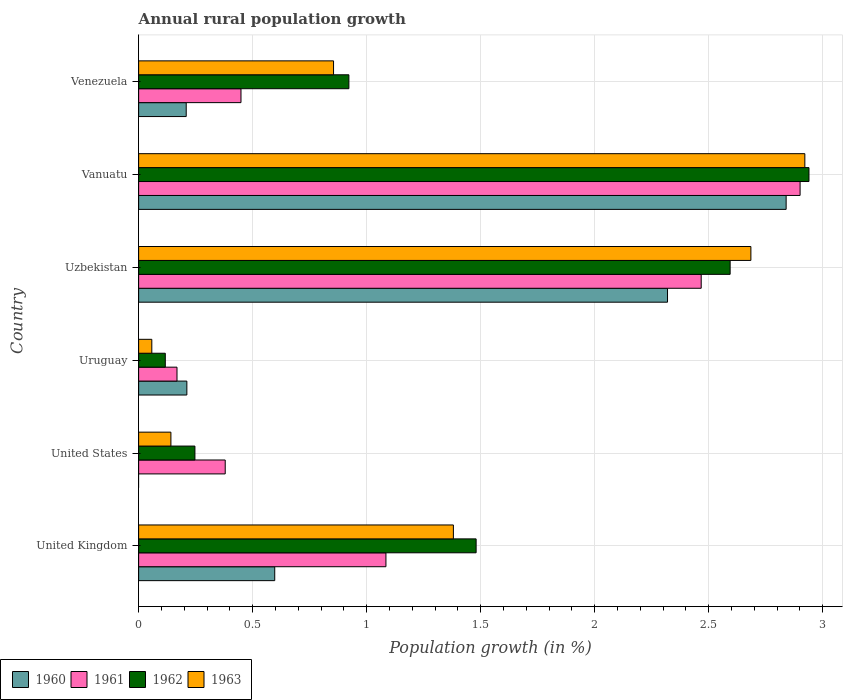Are the number of bars per tick equal to the number of legend labels?
Give a very brief answer. No. Are the number of bars on each tick of the Y-axis equal?
Keep it short and to the point. No. How many bars are there on the 3rd tick from the bottom?
Provide a short and direct response. 4. What is the label of the 3rd group of bars from the top?
Offer a terse response. Uzbekistan. In how many cases, is the number of bars for a given country not equal to the number of legend labels?
Keep it short and to the point. 1. What is the percentage of rural population growth in 1963 in Venezuela?
Your answer should be very brief. 0.85. Across all countries, what is the maximum percentage of rural population growth in 1961?
Provide a short and direct response. 2.9. Across all countries, what is the minimum percentage of rural population growth in 1962?
Offer a terse response. 0.12. In which country was the percentage of rural population growth in 1962 maximum?
Your answer should be very brief. Vanuatu. What is the total percentage of rural population growth in 1961 in the graph?
Keep it short and to the point. 7.45. What is the difference between the percentage of rural population growth in 1960 in Uzbekistan and that in Vanuatu?
Your answer should be compact. -0.52. What is the difference between the percentage of rural population growth in 1960 in Uzbekistan and the percentage of rural population growth in 1962 in Vanuatu?
Offer a terse response. -0.62. What is the average percentage of rural population growth in 1962 per country?
Provide a succinct answer. 1.38. What is the difference between the percentage of rural population growth in 1963 and percentage of rural population growth in 1960 in Vanuatu?
Keep it short and to the point. 0.08. In how many countries, is the percentage of rural population growth in 1960 greater than 0.8 %?
Your answer should be compact. 2. What is the ratio of the percentage of rural population growth in 1961 in Uruguay to that in Venezuela?
Give a very brief answer. 0.37. Is the percentage of rural population growth in 1961 in United States less than that in Vanuatu?
Offer a very short reply. Yes. Is the difference between the percentage of rural population growth in 1963 in United Kingdom and Vanuatu greater than the difference between the percentage of rural population growth in 1960 in United Kingdom and Vanuatu?
Provide a short and direct response. Yes. What is the difference between the highest and the second highest percentage of rural population growth in 1962?
Your answer should be very brief. 0.35. What is the difference between the highest and the lowest percentage of rural population growth in 1961?
Keep it short and to the point. 2.73. In how many countries, is the percentage of rural population growth in 1960 greater than the average percentage of rural population growth in 1960 taken over all countries?
Provide a succinct answer. 2. Is the sum of the percentage of rural population growth in 1963 in Uruguay and Venezuela greater than the maximum percentage of rural population growth in 1960 across all countries?
Ensure brevity in your answer.  No. Is it the case that in every country, the sum of the percentage of rural population growth in 1963 and percentage of rural population growth in 1960 is greater than the percentage of rural population growth in 1962?
Keep it short and to the point. No. How many bars are there?
Offer a very short reply. 23. How many countries are there in the graph?
Ensure brevity in your answer.  6. What is the difference between two consecutive major ticks on the X-axis?
Make the answer very short. 0.5. Does the graph contain any zero values?
Provide a short and direct response. Yes. How are the legend labels stacked?
Keep it short and to the point. Horizontal. What is the title of the graph?
Provide a succinct answer. Annual rural population growth. Does "1986" appear as one of the legend labels in the graph?
Your answer should be compact. No. What is the label or title of the X-axis?
Offer a terse response. Population growth (in %). What is the label or title of the Y-axis?
Offer a terse response. Country. What is the Population growth (in %) in 1960 in United Kingdom?
Offer a terse response. 0.6. What is the Population growth (in %) of 1961 in United Kingdom?
Your answer should be compact. 1.08. What is the Population growth (in %) of 1962 in United Kingdom?
Keep it short and to the point. 1.48. What is the Population growth (in %) in 1963 in United Kingdom?
Make the answer very short. 1.38. What is the Population growth (in %) in 1960 in United States?
Provide a succinct answer. 0. What is the Population growth (in %) of 1961 in United States?
Make the answer very short. 0.38. What is the Population growth (in %) of 1962 in United States?
Your answer should be very brief. 0.25. What is the Population growth (in %) in 1963 in United States?
Your answer should be compact. 0.14. What is the Population growth (in %) of 1960 in Uruguay?
Your response must be concise. 0.21. What is the Population growth (in %) of 1961 in Uruguay?
Provide a succinct answer. 0.17. What is the Population growth (in %) in 1962 in Uruguay?
Keep it short and to the point. 0.12. What is the Population growth (in %) in 1963 in Uruguay?
Your response must be concise. 0.06. What is the Population growth (in %) in 1960 in Uzbekistan?
Provide a short and direct response. 2.32. What is the Population growth (in %) in 1961 in Uzbekistan?
Ensure brevity in your answer.  2.47. What is the Population growth (in %) in 1962 in Uzbekistan?
Offer a terse response. 2.59. What is the Population growth (in %) of 1963 in Uzbekistan?
Offer a terse response. 2.69. What is the Population growth (in %) of 1960 in Vanuatu?
Offer a terse response. 2.84. What is the Population growth (in %) in 1961 in Vanuatu?
Ensure brevity in your answer.  2.9. What is the Population growth (in %) of 1962 in Vanuatu?
Offer a terse response. 2.94. What is the Population growth (in %) of 1963 in Vanuatu?
Provide a short and direct response. 2.92. What is the Population growth (in %) of 1960 in Venezuela?
Provide a succinct answer. 0.21. What is the Population growth (in %) of 1961 in Venezuela?
Offer a very short reply. 0.45. What is the Population growth (in %) in 1962 in Venezuela?
Make the answer very short. 0.92. What is the Population growth (in %) of 1963 in Venezuela?
Make the answer very short. 0.85. Across all countries, what is the maximum Population growth (in %) in 1960?
Your answer should be very brief. 2.84. Across all countries, what is the maximum Population growth (in %) in 1961?
Keep it short and to the point. 2.9. Across all countries, what is the maximum Population growth (in %) in 1962?
Provide a short and direct response. 2.94. Across all countries, what is the maximum Population growth (in %) of 1963?
Offer a terse response. 2.92. Across all countries, what is the minimum Population growth (in %) of 1960?
Provide a succinct answer. 0. Across all countries, what is the minimum Population growth (in %) of 1961?
Offer a very short reply. 0.17. Across all countries, what is the minimum Population growth (in %) of 1962?
Give a very brief answer. 0.12. Across all countries, what is the minimum Population growth (in %) in 1963?
Your answer should be compact. 0.06. What is the total Population growth (in %) in 1960 in the graph?
Provide a short and direct response. 6.18. What is the total Population growth (in %) of 1961 in the graph?
Provide a short and direct response. 7.45. What is the total Population growth (in %) in 1962 in the graph?
Provide a short and direct response. 8.3. What is the total Population growth (in %) of 1963 in the graph?
Offer a very short reply. 8.04. What is the difference between the Population growth (in %) in 1961 in United Kingdom and that in United States?
Your answer should be very brief. 0.7. What is the difference between the Population growth (in %) in 1962 in United Kingdom and that in United States?
Your answer should be very brief. 1.23. What is the difference between the Population growth (in %) of 1963 in United Kingdom and that in United States?
Offer a terse response. 1.24. What is the difference between the Population growth (in %) in 1960 in United Kingdom and that in Uruguay?
Offer a very short reply. 0.39. What is the difference between the Population growth (in %) of 1961 in United Kingdom and that in Uruguay?
Your answer should be very brief. 0.92. What is the difference between the Population growth (in %) in 1962 in United Kingdom and that in Uruguay?
Make the answer very short. 1.36. What is the difference between the Population growth (in %) in 1963 in United Kingdom and that in Uruguay?
Provide a succinct answer. 1.32. What is the difference between the Population growth (in %) of 1960 in United Kingdom and that in Uzbekistan?
Your response must be concise. -1.72. What is the difference between the Population growth (in %) of 1961 in United Kingdom and that in Uzbekistan?
Offer a terse response. -1.38. What is the difference between the Population growth (in %) of 1962 in United Kingdom and that in Uzbekistan?
Provide a succinct answer. -1.11. What is the difference between the Population growth (in %) of 1963 in United Kingdom and that in Uzbekistan?
Your answer should be compact. -1.3. What is the difference between the Population growth (in %) of 1960 in United Kingdom and that in Vanuatu?
Your answer should be compact. -2.24. What is the difference between the Population growth (in %) in 1961 in United Kingdom and that in Vanuatu?
Your response must be concise. -1.82. What is the difference between the Population growth (in %) in 1962 in United Kingdom and that in Vanuatu?
Provide a short and direct response. -1.46. What is the difference between the Population growth (in %) in 1963 in United Kingdom and that in Vanuatu?
Ensure brevity in your answer.  -1.54. What is the difference between the Population growth (in %) in 1960 in United Kingdom and that in Venezuela?
Give a very brief answer. 0.39. What is the difference between the Population growth (in %) in 1961 in United Kingdom and that in Venezuela?
Keep it short and to the point. 0.64. What is the difference between the Population growth (in %) in 1962 in United Kingdom and that in Venezuela?
Your answer should be compact. 0.56. What is the difference between the Population growth (in %) of 1963 in United Kingdom and that in Venezuela?
Make the answer very short. 0.53. What is the difference between the Population growth (in %) in 1961 in United States and that in Uruguay?
Your response must be concise. 0.21. What is the difference between the Population growth (in %) in 1962 in United States and that in Uruguay?
Provide a succinct answer. 0.13. What is the difference between the Population growth (in %) in 1963 in United States and that in Uruguay?
Give a very brief answer. 0.08. What is the difference between the Population growth (in %) of 1961 in United States and that in Uzbekistan?
Give a very brief answer. -2.09. What is the difference between the Population growth (in %) in 1962 in United States and that in Uzbekistan?
Provide a short and direct response. -2.35. What is the difference between the Population growth (in %) of 1963 in United States and that in Uzbekistan?
Offer a very short reply. -2.54. What is the difference between the Population growth (in %) in 1961 in United States and that in Vanuatu?
Offer a very short reply. -2.52. What is the difference between the Population growth (in %) of 1962 in United States and that in Vanuatu?
Provide a succinct answer. -2.69. What is the difference between the Population growth (in %) of 1963 in United States and that in Vanuatu?
Ensure brevity in your answer.  -2.78. What is the difference between the Population growth (in %) of 1961 in United States and that in Venezuela?
Make the answer very short. -0.07. What is the difference between the Population growth (in %) in 1962 in United States and that in Venezuela?
Provide a succinct answer. -0.68. What is the difference between the Population growth (in %) of 1963 in United States and that in Venezuela?
Your response must be concise. -0.71. What is the difference between the Population growth (in %) of 1960 in Uruguay and that in Uzbekistan?
Your answer should be compact. -2.11. What is the difference between the Population growth (in %) in 1961 in Uruguay and that in Uzbekistan?
Make the answer very short. -2.3. What is the difference between the Population growth (in %) in 1962 in Uruguay and that in Uzbekistan?
Keep it short and to the point. -2.48. What is the difference between the Population growth (in %) of 1963 in Uruguay and that in Uzbekistan?
Your answer should be very brief. -2.63. What is the difference between the Population growth (in %) of 1960 in Uruguay and that in Vanuatu?
Offer a terse response. -2.63. What is the difference between the Population growth (in %) of 1961 in Uruguay and that in Vanuatu?
Offer a terse response. -2.73. What is the difference between the Population growth (in %) in 1962 in Uruguay and that in Vanuatu?
Provide a succinct answer. -2.82. What is the difference between the Population growth (in %) of 1963 in Uruguay and that in Vanuatu?
Provide a short and direct response. -2.86. What is the difference between the Population growth (in %) in 1960 in Uruguay and that in Venezuela?
Provide a short and direct response. 0. What is the difference between the Population growth (in %) in 1961 in Uruguay and that in Venezuela?
Your response must be concise. -0.28. What is the difference between the Population growth (in %) in 1962 in Uruguay and that in Venezuela?
Your answer should be very brief. -0.81. What is the difference between the Population growth (in %) in 1963 in Uruguay and that in Venezuela?
Keep it short and to the point. -0.8. What is the difference between the Population growth (in %) in 1960 in Uzbekistan and that in Vanuatu?
Offer a very short reply. -0.52. What is the difference between the Population growth (in %) of 1961 in Uzbekistan and that in Vanuatu?
Offer a terse response. -0.43. What is the difference between the Population growth (in %) in 1962 in Uzbekistan and that in Vanuatu?
Your response must be concise. -0.35. What is the difference between the Population growth (in %) in 1963 in Uzbekistan and that in Vanuatu?
Offer a terse response. -0.24. What is the difference between the Population growth (in %) in 1960 in Uzbekistan and that in Venezuela?
Provide a short and direct response. 2.11. What is the difference between the Population growth (in %) in 1961 in Uzbekistan and that in Venezuela?
Give a very brief answer. 2.02. What is the difference between the Population growth (in %) of 1962 in Uzbekistan and that in Venezuela?
Your response must be concise. 1.67. What is the difference between the Population growth (in %) in 1963 in Uzbekistan and that in Venezuela?
Offer a terse response. 1.83. What is the difference between the Population growth (in %) in 1960 in Vanuatu and that in Venezuela?
Your answer should be very brief. 2.63. What is the difference between the Population growth (in %) in 1961 in Vanuatu and that in Venezuela?
Keep it short and to the point. 2.45. What is the difference between the Population growth (in %) of 1962 in Vanuatu and that in Venezuela?
Ensure brevity in your answer.  2.02. What is the difference between the Population growth (in %) of 1963 in Vanuatu and that in Venezuela?
Give a very brief answer. 2.07. What is the difference between the Population growth (in %) in 1960 in United Kingdom and the Population growth (in %) in 1961 in United States?
Offer a very short reply. 0.22. What is the difference between the Population growth (in %) in 1960 in United Kingdom and the Population growth (in %) in 1963 in United States?
Your answer should be very brief. 0.46. What is the difference between the Population growth (in %) in 1961 in United Kingdom and the Population growth (in %) in 1962 in United States?
Keep it short and to the point. 0.84. What is the difference between the Population growth (in %) in 1961 in United Kingdom and the Population growth (in %) in 1963 in United States?
Offer a terse response. 0.94. What is the difference between the Population growth (in %) of 1962 in United Kingdom and the Population growth (in %) of 1963 in United States?
Provide a succinct answer. 1.34. What is the difference between the Population growth (in %) in 1960 in United Kingdom and the Population growth (in %) in 1961 in Uruguay?
Your answer should be compact. 0.43. What is the difference between the Population growth (in %) of 1960 in United Kingdom and the Population growth (in %) of 1962 in Uruguay?
Keep it short and to the point. 0.48. What is the difference between the Population growth (in %) of 1960 in United Kingdom and the Population growth (in %) of 1963 in Uruguay?
Offer a very short reply. 0.54. What is the difference between the Population growth (in %) of 1961 in United Kingdom and the Population growth (in %) of 1963 in Uruguay?
Provide a succinct answer. 1.03. What is the difference between the Population growth (in %) of 1962 in United Kingdom and the Population growth (in %) of 1963 in Uruguay?
Provide a short and direct response. 1.42. What is the difference between the Population growth (in %) in 1960 in United Kingdom and the Population growth (in %) in 1961 in Uzbekistan?
Give a very brief answer. -1.87. What is the difference between the Population growth (in %) of 1960 in United Kingdom and the Population growth (in %) of 1962 in Uzbekistan?
Your answer should be very brief. -2. What is the difference between the Population growth (in %) of 1960 in United Kingdom and the Population growth (in %) of 1963 in Uzbekistan?
Provide a succinct answer. -2.09. What is the difference between the Population growth (in %) of 1961 in United Kingdom and the Population growth (in %) of 1962 in Uzbekistan?
Offer a terse response. -1.51. What is the difference between the Population growth (in %) in 1961 in United Kingdom and the Population growth (in %) in 1963 in Uzbekistan?
Ensure brevity in your answer.  -1.6. What is the difference between the Population growth (in %) in 1962 in United Kingdom and the Population growth (in %) in 1963 in Uzbekistan?
Provide a short and direct response. -1.21. What is the difference between the Population growth (in %) of 1960 in United Kingdom and the Population growth (in %) of 1961 in Vanuatu?
Offer a very short reply. -2.3. What is the difference between the Population growth (in %) in 1960 in United Kingdom and the Population growth (in %) in 1962 in Vanuatu?
Provide a short and direct response. -2.34. What is the difference between the Population growth (in %) of 1960 in United Kingdom and the Population growth (in %) of 1963 in Vanuatu?
Provide a succinct answer. -2.32. What is the difference between the Population growth (in %) in 1961 in United Kingdom and the Population growth (in %) in 1962 in Vanuatu?
Give a very brief answer. -1.86. What is the difference between the Population growth (in %) of 1961 in United Kingdom and the Population growth (in %) of 1963 in Vanuatu?
Offer a very short reply. -1.84. What is the difference between the Population growth (in %) of 1962 in United Kingdom and the Population growth (in %) of 1963 in Vanuatu?
Your answer should be compact. -1.44. What is the difference between the Population growth (in %) in 1960 in United Kingdom and the Population growth (in %) in 1961 in Venezuela?
Make the answer very short. 0.15. What is the difference between the Population growth (in %) of 1960 in United Kingdom and the Population growth (in %) of 1962 in Venezuela?
Ensure brevity in your answer.  -0.33. What is the difference between the Population growth (in %) in 1960 in United Kingdom and the Population growth (in %) in 1963 in Venezuela?
Your response must be concise. -0.26. What is the difference between the Population growth (in %) in 1961 in United Kingdom and the Population growth (in %) in 1962 in Venezuela?
Provide a succinct answer. 0.16. What is the difference between the Population growth (in %) of 1961 in United Kingdom and the Population growth (in %) of 1963 in Venezuela?
Your response must be concise. 0.23. What is the difference between the Population growth (in %) of 1962 in United Kingdom and the Population growth (in %) of 1963 in Venezuela?
Ensure brevity in your answer.  0.63. What is the difference between the Population growth (in %) in 1961 in United States and the Population growth (in %) in 1962 in Uruguay?
Provide a short and direct response. 0.26. What is the difference between the Population growth (in %) in 1961 in United States and the Population growth (in %) in 1963 in Uruguay?
Make the answer very short. 0.32. What is the difference between the Population growth (in %) in 1962 in United States and the Population growth (in %) in 1963 in Uruguay?
Provide a short and direct response. 0.19. What is the difference between the Population growth (in %) in 1961 in United States and the Population growth (in %) in 1962 in Uzbekistan?
Provide a succinct answer. -2.21. What is the difference between the Population growth (in %) of 1961 in United States and the Population growth (in %) of 1963 in Uzbekistan?
Your answer should be very brief. -2.31. What is the difference between the Population growth (in %) in 1962 in United States and the Population growth (in %) in 1963 in Uzbekistan?
Your answer should be very brief. -2.44. What is the difference between the Population growth (in %) in 1961 in United States and the Population growth (in %) in 1962 in Vanuatu?
Make the answer very short. -2.56. What is the difference between the Population growth (in %) in 1961 in United States and the Population growth (in %) in 1963 in Vanuatu?
Your answer should be very brief. -2.54. What is the difference between the Population growth (in %) in 1962 in United States and the Population growth (in %) in 1963 in Vanuatu?
Ensure brevity in your answer.  -2.67. What is the difference between the Population growth (in %) of 1961 in United States and the Population growth (in %) of 1962 in Venezuela?
Provide a succinct answer. -0.54. What is the difference between the Population growth (in %) of 1961 in United States and the Population growth (in %) of 1963 in Venezuela?
Keep it short and to the point. -0.48. What is the difference between the Population growth (in %) of 1962 in United States and the Population growth (in %) of 1963 in Venezuela?
Provide a short and direct response. -0.61. What is the difference between the Population growth (in %) in 1960 in Uruguay and the Population growth (in %) in 1961 in Uzbekistan?
Keep it short and to the point. -2.26. What is the difference between the Population growth (in %) in 1960 in Uruguay and the Population growth (in %) in 1962 in Uzbekistan?
Give a very brief answer. -2.38. What is the difference between the Population growth (in %) of 1960 in Uruguay and the Population growth (in %) of 1963 in Uzbekistan?
Keep it short and to the point. -2.47. What is the difference between the Population growth (in %) of 1961 in Uruguay and the Population growth (in %) of 1962 in Uzbekistan?
Ensure brevity in your answer.  -2.43. What is the difference between the Population growth (in %) in 1961 in Uruguay and the Population growth (in %) in 1963 in Uzbekistan?
Keep it short and to the point. -2.52. What is the difference between the Population growth (in %) of 1962 in Uruguay and the Population growth (in %) of 1963 in Uzbekistan?
Offer a very short reply. -2.57. What is the difference between the Population growth (in %) in 1960 in Uruguay and the Population growth (in %) in 1961 in Vanuatu?
Give a very brief answer. -2.69. What is the difference between the Population growth (in %) of 1960 in Uruguay and the Population growth (in %) of 1962 in Vanuatu?
Keep it short and to the point. -2.73. What is the difference between the Population growth (in %) in 1960 in Uruguay and the Population growth (in %) in 1963 in Vanuatu?
Give a very brief answer. -2.71. What is the difference between the Population growth (in %) of 1961 in Uruguay and the Population growth (in %) of 1962 in Vanuatu?
Your response must be concise. -2.77. What is the difference between the Population growth (in %) in 1961 in Uruguay and the Population growth (in %) in 1963 in Vanuatu?
Make the answer very short. -2.75. What is the difference between the Population growth (in %) in 1962 in Uruguay and the Population growth (in %) in 1963 in Vanuatu?
Your answer should be very brief. -2.8. What is the difference between the Population growth (in %) in 1960 in Uruguay and the Population growth (in %) in 1961 in Venezuela?
Offer a very short reply. -0.24. What is the difference between the Population growth (in %) in 1960 in Uruguay and the Population growth (in %) in 1962 in Venezuela?
Offer a very short reply. -0.71. What is the difference between the Population growth (in %) in 1960 in Uruguay and the Population growth (in %) in 1963 in Venezuela?
Your answer should be very brief. -0.64. What is the difference between the Population growth (in %) of 1961 in Uruguay and the Population growth (in %) of 1962 in Venezuela?
Provide a succinct answer. -0.75. What is the difference between the Population growth (in %) in 1961 in Uruguay and the Population growth (in %) in 1963 in Venezuela?
Provide a succinct answer. -0.69. What is the difference between the Population growth (in %) of 1962 in Uruguay and the Population growth (in %) of 1963 in Venezuela?
Offer a terse response. -0.74. What is the difference between the Population growth (in %) of 1960 in Uzbekistan and the Population growth (in %) of 1961 in Vanuatu?
Give a very brief answer. -0.58. What is the difference between the Population growth (in %) of 1960 in Uzbekistan and the Population growth (in %) of 1962 in Vanuatu?
Provide a succinct answer. -0.62. What is the difference between the Population growth (in %) in 1960 in Uzbekistan and the Population growth (in %) in 1963 in Vanuatu?
Offer a terse response. -0.6. What is the difference between the Population growth (in %) in 1961 in Uzbekistan and the Population growth (in %) in 1962 in Vanuatu?
Give a very brief answer. -0.47. What is the difference between the Population growth (in %) of 1961 in Uzbekistan and the Population growth (in %) of 1963 in Vanuatu?
Keep it short and to the point. -0.45. What is the difference between the Population growth (in %) of 1962 in Uzbekistan and the Population growth (in %) of 1963 in Vanuatu?
Offer a very short reply. -0.33. What is the difference between the Population growth (in %) of 1960 in Uzbekistan and the Population growth (in %) of 1961 in Venezuela?
Give a very brief answer. 1.87. What is the difference between the Population growth (in %) in 1960 in Uzbekistan and the Population growth (in %) in 1962 in Venezuela?
Your response must be concise. 1.4. What is the difference between the Population growth (in %) in 1960 in Uzbekistan and the Population growth (in %) in 1963 in Venezuela?
Provide a succinct answer. 1.46. What is the difference between the Population growth (in %) of 1961 in Uzbekistan and the Population growth (in %) of 1962 in Venezuela?
Your answer should be very brief. 1.55. What is the difference between the Population growth (in %) of 1961 in Uzbekistan and the Population growth (in %) of 1963 in Venezuela?
Provide a short and direct response. 1.61. What is the difference between the Population growth (in %) of 1962 in Uzbekistan and the Population growth (in %) of 1963 in Venezuela?
Keep it short and to the point. 1.74. What is the difference between the Population growth (in %) of 1960 in Vanuatu and the Population growth (in %) of 1961 in Venezuela?
Provide a succinct answer. 2.39. What is the difference between the Population growth (in %) in 1960 in Vanuatu and the Population growth (in %) in 1962 in Venezuela?
Your response must be concise. 1.92. What is the difference between the Population growth (in %) in 1960 in Vanuatu and the Population growth (in %) in 1963 in Venezuela?
Give a very brief answer. 1.99. What is the difference between the Population growth (in %) in 1961 in Vanuatu and the Population growth (in %) in 1962 in Venezuela?
Ensure brevity in your answer.  1.98. What is the difference between the Population growth (in %) of 1961 in Vanuatu and the Population growth (in %) of 1963 in Venezuela?
Make the answer very short. 2.05. What is the difference between the Population growth (in %) in 1962 in Vanuatu and the Population growth (in %) in 1963 in Venezuela?
Your answer should be compact. 2.09. What is the average Population growth (in %) in 1960 per country?
Offer a very short reply. 1.03. What is the average Population growth (in %) of 1961 per country?
Keep it short and to the point. 1.24. What is the average Population growth (in %) in 1962 per country?
Make the answer very short. 1.38. What is the average Population growth (in %) in 1963 per country?
Your response must be concise. 1.34. What is the difference between the Population growth (in %) of 1960 and Population growth (in %) of 1961 in United Kingdom?
Keep it short and to the point. -0.49. What is the difference between the Population growth (in %) of 1960 and Population growth (in %) of 1962 in United Kingdom?
Make the answer very short. -0.88. What is the difference between the Population growth (in %) in 1960 and Population growth (in %) in 1963 in United Kingdom?
Ensure brevity in your answer.  -0.78. What is the difference between the Population growth (in %) in 1961 and Population growth (in %) in 1962 in United Kingdom?
Ensure brevity in your answer.  -0.4. What is the difference between the Population growth (in %) of 1961 and Population growth (in %) of 1963 in United Kingdom?
Your response must be concise. -0.3. What is the difference between the Population growth (in %) of 1962 and Population growth (in %) of 1963 in United Kingdom?
Provide a short and direct response. 0.1. What is the difference between the Population growth (in %) in 1961 and Population growth (in %) in 1962 in United States?
Offer a very short reply. 0.13. What is the difference between the Population growth (in %) of 1961 and Population growth (in %) of 1963 in United States?
Provide a short and direct response. 0.24. What is the difference between the Population growth (in %) of 1962 and Population growth (in %) of 1963 in United States?
Ensure brevity in your answer.  0.11. What is the difference between the Population growth (in %) in 1960 and Population growth (in %) in 1961 in Uruguay?
Provide a succinct answer. 0.04. What is the difference between the Population growth (in %) of 1960 and Population growth (in %) of 1962 in Uruguay?
Your answer should be very brief. 0.09. What is the difference between the Population growth (in %) of 1960 and Population growth (in %) of 1963 in Uruguay?
Provide a short and direct response. 0.15. What is the difference between the Population growth (in %) of 1961 and Population growth (in %) of 1962 in Uruguay?
Your response must be concise. 0.05. What is the difference between the Population growth (in %) in 1961 and Population growth (in %) in 1963 in Uruguay?
Ensure brevity in your answer.  0.11. What is the difference between the Population growth (in %) of 1962 and Population growth (in %) of 1963 in Uruguay?
Make the answer very short. 0.06. What is the difference between the Population growth (in %) of 1960 and Population growth (in %) of 1961 in Uzbekistan?
Your answer should be very brief. -0.15. What is the difference between the Population growth (in %) in 1960 and Population growth (in %) in 1962 in Uzbekistan?
Ensure brevity in your answer.  -0.27. What is the difference between the Population growth (in %) in 1960 and Population growth (in %) in 1963 in Uzbekistan?
Offer a terse response. -0.37. What is the difference between the Population growth (in %) of 1961 and Population growth (in %) of 1962 in Uzbekistan?
Provide a short and direct response. -0.13. What is the difference between the Population growth (in %) in 1961 and Population growth (in %) in 1963 in Uzbekistan?
Ensure brevity in your answer.  -0.22. What is the difference between the Population growth (in %) of 1962 and Population growth (in %) of 1963 in Uzbekistan?
Keep it short and to the point. -0.09. What is the difference between the Population growth (in %) in 1960 and Population growth (in %) in 1961 in Vanuatu?
Keep it short and to the point. -0.06. What is the difference between the Population growth (in %) of 1960 and Population growth (in %) of 1962 in Vanuatu?
Provide a succinct answer. -0.1. What is the difference between the Population growth (in %) in 1960 and Population growth (in %) in 1963 in Vanuatu?
Keep it short and to the point. -0.08. What is the difference between the Population growth (in %) in 1961 and Population growth (in %) in 1962 in Vanuatu?
Give a very brief answer. -0.04. What is the difference between the Population growth (in %) of 1961 and Population growth (in %) of 1963 in Vanuatu?
Your answer should be very brief. -0.02. What is the difference between the Population growth (in %) of 1962 and Population growth (in %) of 1963 in Vanuatu?
Keep it short and to the point. 0.02. What is the difference between the Population growth (in %) in 1960 and Population growth (in %) in 1961 in Venezuela?
Make the answer very short. -0.24. What is the difference between the Population growth (in %) of 1960 and Population growth (in %) of 1962 in Venezuela?
Your response must be concise. -0.71. What is the difference between the Population growth (in %) in 1960 and Population growth (in %) in 1963 in Venezuela?
Make the answer very short. -0.65. What is the difference between the Population growth (in %) in 1961 and Population growth (in %) in 1962 in Venezuela?
Your response must be concise. -0.47. What is the difference between the Population growth (in %) of 1961 and Population growth (in %) of 1963 in Venezuela?
Your answer should be very brief. -0.41. What is the difference between the Population growth (in %) in 1962 and Population growth (in %) in 1963 in Venezuela?
Provide a succinct answer. 0.07. What is the ratio of the Population growth (in %) in 1961 in United Kingdom to that in United States?
Make the answer very short. 2.86. What is the ratio of the Population growth (in %) in 1962 in United Kingdom to that in United States?
Keep it short and to the point. 5.99. What is the ratio of the Population growth (in %) of 1963 in United Kingdom to that in United States?
Offer a very short reply. 9.75. What is the ratio of the Population growth (in %) of 1960 in United Kingdom to that in Uruguay?
Provide a short and direct response. 2.82. What is the ratio of the Population growth (in %) in 1961 in United Kingdom to that in Uruguay?
Provide a short and direct response. 6.44. What is the ratio of the Population growth (in %) of 1962 in United Kingdom to that in Uruguay?
Keep it short and to the point. 12.66. What is the ratio of the Population growth (in %) of 1963 in United Kingdom to that in Uruguay?
Keep it short and to the point. 23.87. What is the ratio of the Population growth (in %) of 1960 in United Kingdom to that in Uzbekistan?
Ensure brevity in your answer.  0.26. What is the ratio of the Population growth (in %) of 1961 in United Kingdom to that in Uzbekistan?
Ensure brevity in your answer.  0.44. What is the ratio of the Population growth (in %) in 1962 in United Kingdom to that in Uzbekistan?
Ensure brevity in your answer.  0.57. What is the ratio of the Population growth (in %) of 1963 in United Kingdom to that in Uzbekistan?
Keep it short and to the point. 0.51. What is the ratio of the Population growth (in %) of 1960 in United Kingdom to that in Vanuatu?
Offer a terse response. 0.21. What is the ratio of the Population growth (in %) in 1961 in United Kingdom to that in Vanuatu?
Your response must be concise. 0.37. What is the ratio of the Population growth (in %) of 1962 in United Kingdom to that in Vanuatu?
Offer a terse response. 0.5. What is the ratio of the Population growth (in %) of 1963 in United Kingdom to that in Vanuatu?
Make the answer very short. 0.47. What is the ratio of the Population growth (in %) in 1960 in United Kingdom to that in Venezuela?
Your answer should be compact. 2.86. What is the ratio of the Population growth (in %) in 1961 in United Kingdom to that in Venezuela?
Offer a very short reply. 2.42. What is the ratio of the Population growth (in %) of 1962 in United Kingdom to that in Venezuela?
Ensure brevity in your answer.  1.61. What is the ratio of the Population growth (in %) of 1963 in United Kingdom to that in Venezuela?
Offer a very short reply. 1.61. What is the ratio of the Population growth (in %) in 1961 in United States to that in Uruguay?
Provide a succinct answer. 2.26. What is the ratio of the Population growth (in %) of 1962 in United States to that in Uruguay?
Give a very brief answer. 2.11. What is the ratio of the Population growth (in %) of 1963 in United States to that in Uruguay?
Provide a short and direct response. 2.45. What is the ratio of the Population growth (in %) of 1961 in United States to that in Uzbekistan?
Your answer should be compact. 0.15. What is the ratio of the Population growth (in %) of 1962 in United States to that in Uzbekistan?
Your response must be concise. 0.1. What is the ratio of the Population growth (in %) in 1963 in United States to that in Uzbekistan?
Give a very brief answer. 0.05. What is the ratio of the Population growth (in %) in 1961 in United States to that in Vanuatu?
Your answer should be compact. 0.13. What is the ratio of the Population growth (in %) in 1962 in United States to that in Vanuatu?
Provide a succinct answer. 0.08. What is the ratio of the Population growth (in %) of 1963 in United States to that in Vanuatu?
Offer a very short reply. 0.05. What is the ratio of the Population growth (in %) of 1961 in United States to that in Venezuela?
Make the answer very short. 0.85. What is the ratio of the Population growth (in %) of 1962 in United States to that in Venezuela?
Your answer should be compact. 0.27. What is the ratio of the Population growth (in %) in 1963 in United States to that in Venezuela?
Give a very brief answer. 0.17. What is the ratio of the Population growth (in %) in 1960 in Uruguay to that in Uzbekistan?
Offer a very short reply. 0.09. What is the ratio of the Population growth (in %) in 1961 in Uruguay to that in Uzbekistan?
Make the answer very short. 0.07. What is the ratio of the Population growth (in %) of 1962 in Uruguay to that in Uzbekistan?
Provide a short and direct response. 0.05. What is the ratio of the Population growth (in %) of 1963 in Uruguay to that in Uzbekistan?
Offer a very short reply. 0.02. What is the ratio of the Population growth (in %) of 1960 in Uruguay to that in Vanuatu?
Provide a short and direct response. 0.07. What is the ratio of the Population growth (in %) of 1961 in Uruguay to that in Vanuatu?
Offer a terse response. 0.06. What is the ratio of the Population growth (in %) of 1962 in Uruguay to that in Vanuatu?
Give a very brief answer. 0.04. What is the ratio of the Population growth (in %) of 1963 in Uruguay to that in Vanuatu?
Offer a terse response. 0.02. What is the ratio of the Population growth (in %) in 1960 in Uruguay to that in Venezuela?
Offer a very short reply. 1.01. What is the ratio of the Population growth (in %) in 1961 in Uruguay to that in Venezuela?
Make the answer very short. 0.37. What is the ratio of the Population growth (in %) of 1962 in Uruguay to that in Venezuela?
Offer a very short reply. 0.13. What is the ratio of the Population growth (in %) in 1963 in Uruguay to that in Venezuela?
Give a very brief answer. 0.07. What is the ratio of the Population growth (in %) of 1960 in Uzbekistan to that in Vanuatu?
Ensure brevity in your answer.  0.82. What is the ratio of the Population growth (in %) in 1961 in Uzbekistan to that in Vanuatu?
Your answer should be compact. 0.85. What is the ratio of the Population growth (in %) in 1962 in Uzbekistan to that in Vanuatu?
Your answer should be very brief. 0.88. What is the ratio of the Population growth (in %) of 1963 in Uzbekistan to that in Vanuatu?
Your response must be concise. 0.92. What is the ratio of the Population growth (in %) in 1960 in Uzbekistan to that in Venezuela?
Your answer should be compact. 11.11. What is the ratio of the Population growth (in %) in 1961 in Uzbekistan to that in Venezuela?
Offer a terse response. 5.5. What is the ratio of the Population growth (in %) of 1962 in Uzbekistan to that in Venezuela?
Your response must be concise. 2.81. What is the ratio of the Population growth (in %) in 1963 in Uzbekistan to that in Venezuela?
Provide a succinct answer. 3.14. What is the ratio of the Population growth (in %) in 1960 in Vanuatu to that in Venezuela?
Give a very brief answer. 13.61. What is the ratio of the Population growth (in %) of 1961 in Vanuatu to that in Venezuela?
Your answer should be compact. 6.46. What is the ratio of the Population growth (in %) in 1962 in Vanuatu to that in Venezuela?
Offer a terse response. 3.19. What is the ratio of the Population growth (in %) of 1963 in Vanuatu to that in Venezuela?
Provide a short and direct response. 3.42. What is the difference between the highest and the second highest Population growth (in %) in 1960?
Give a very brief answer. 0.52. What is the difference between the highest and the second highest Population growth (in %) in 1961?
Your response must be concise. 0.43. What is the difference between the highest and the second highest Population growth (in %) in 1962?
Keep it short and to the point. 0.35. What is the difference between the highest and the second highest Population growth (in %) in 1963?
Your answer should be very brief. 0.24. What is the difference between the highest and the lowest Population growth (in %) in 1960?
Keep it short and to the point. 2.84. What is the difference between the highest and the lowest Population growth (in %) in 1961?
Your answer should be compact. 2.73. What is the difference between the highest and the lowest Population growth (in %) of 1962?
Make the answer very short. 2.82. What is the difference between the highest and the lowest Population growth (in %) of 1963?
Your answer should be compact. 2.86. 